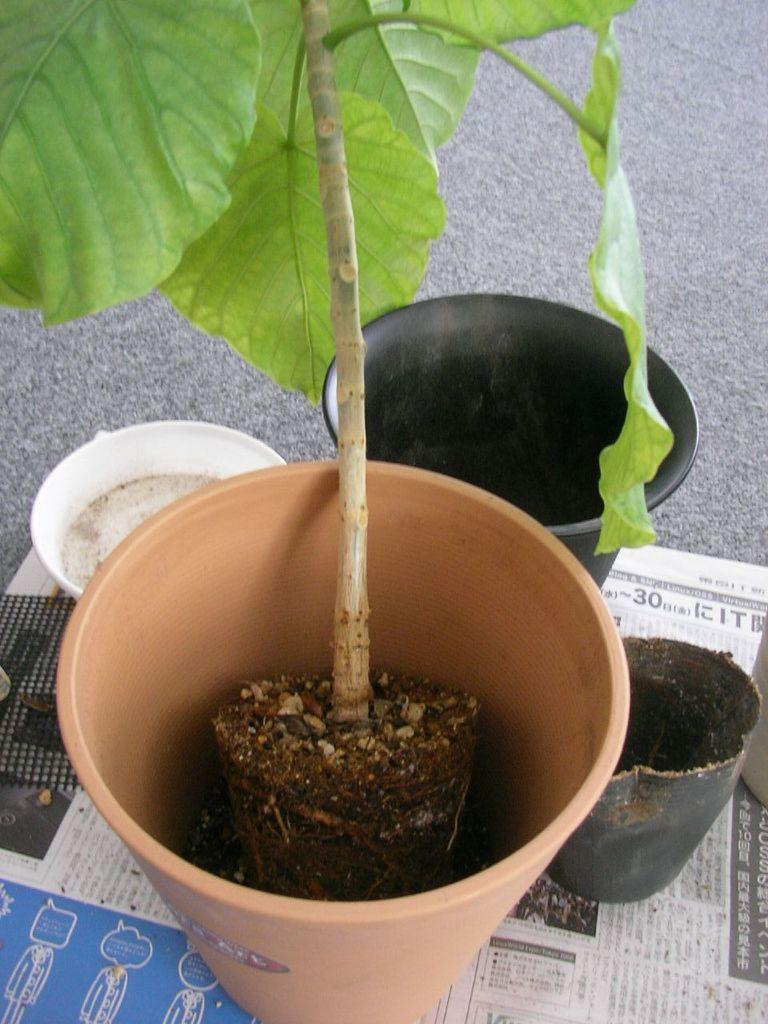What type of objects can be seen in the image? There are flower pots, papers, and a bowl in the image. What is growing in the flower pots? There is a plant in the image, which is growing in one of the flower pots. Where are these objects placed? All of these objects are placed on a platform. What type of toothbrush is being used to water the plant in the image? There is no toothbrush present in the image, and the plant is not being watered. 